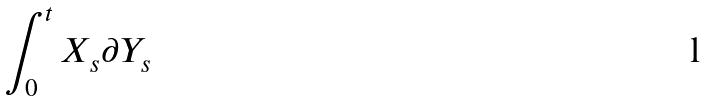<formula> <loc_0><loc_0><loc_500><loc_500>\int _ { 0 } ^ { t } X _ { s } \partial Y _ { s }</formula> 